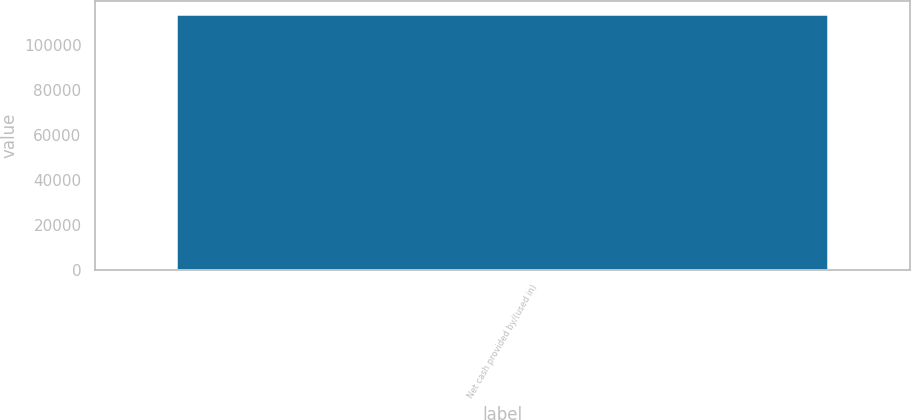Convert chart to OTSL. <chart><loc_0><loc_0><loc_500><loc_500><bar_chart><fcel>Net cash provided by/(used in)<nl><fcel>113725<nl></chart> 